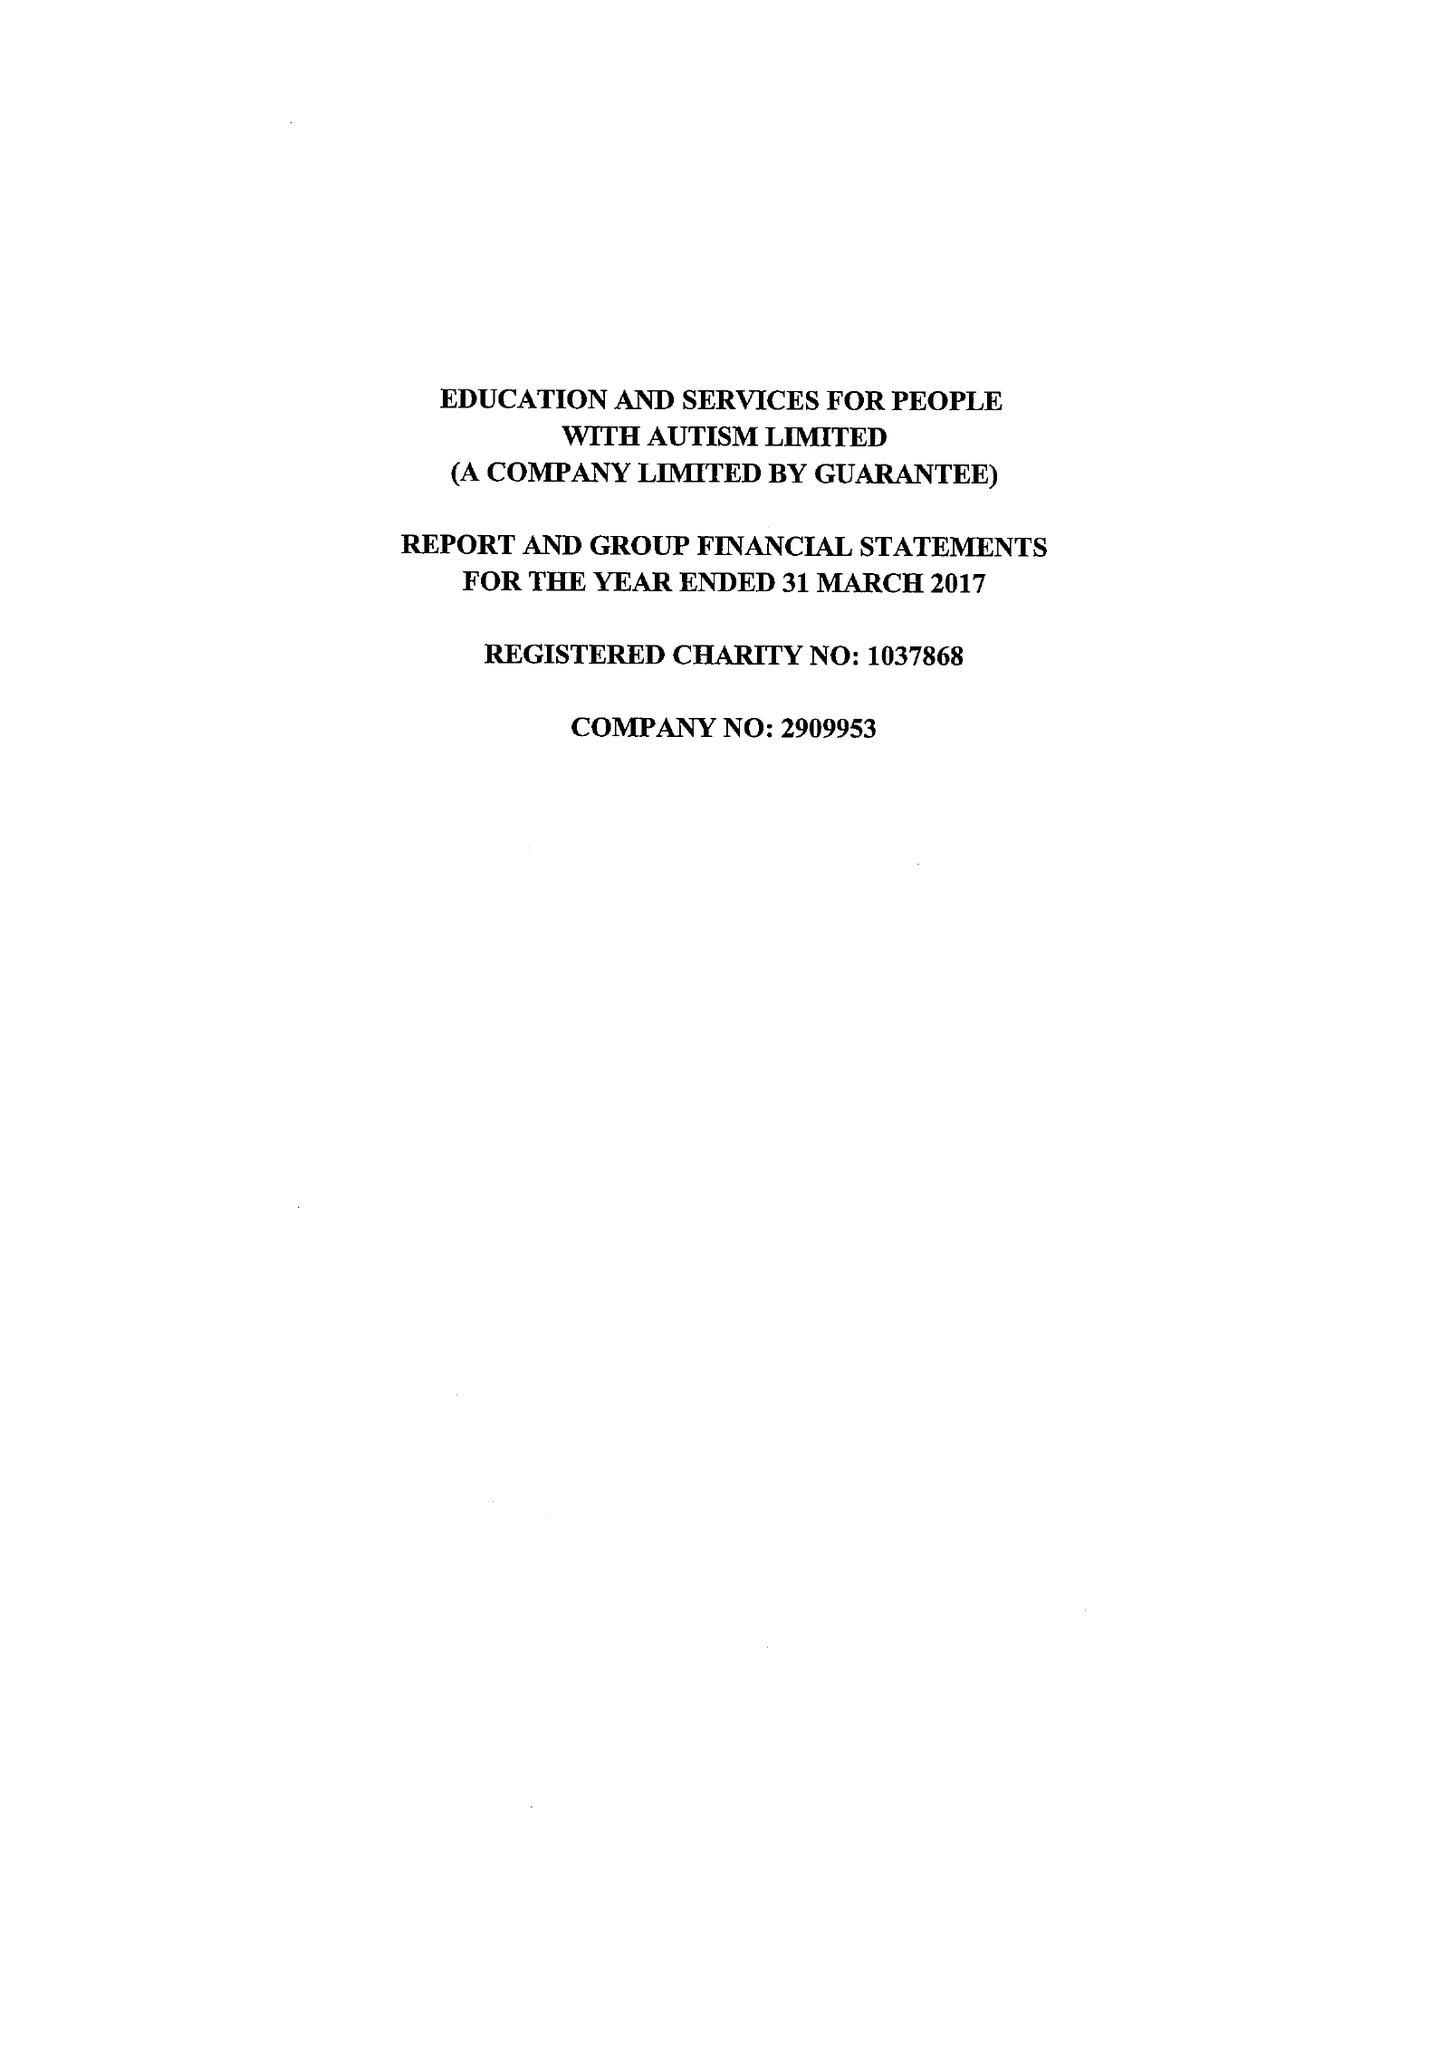What is the value for the report_date?
Answer the question using a single word or phrase. 2017-03-31 